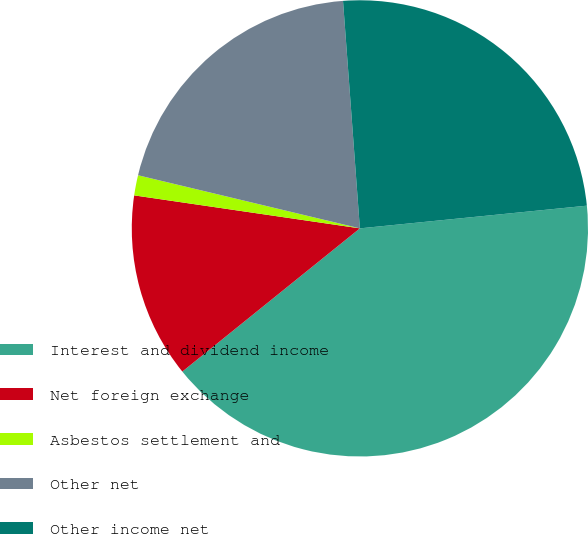<chart> <loc_0><loc_0><loc_500><loc_500><pie_chart><fcel>Interest and dividend income<fcel>Net foreign exchange<fcel>Asbestos settlement and<fcel>Other net<fcel>Other income net<nl><fcel>40.78%<fcel>13.11%<fcel>1.43%<fcel>20.08%<fcel>24.59%<nl></chart> 